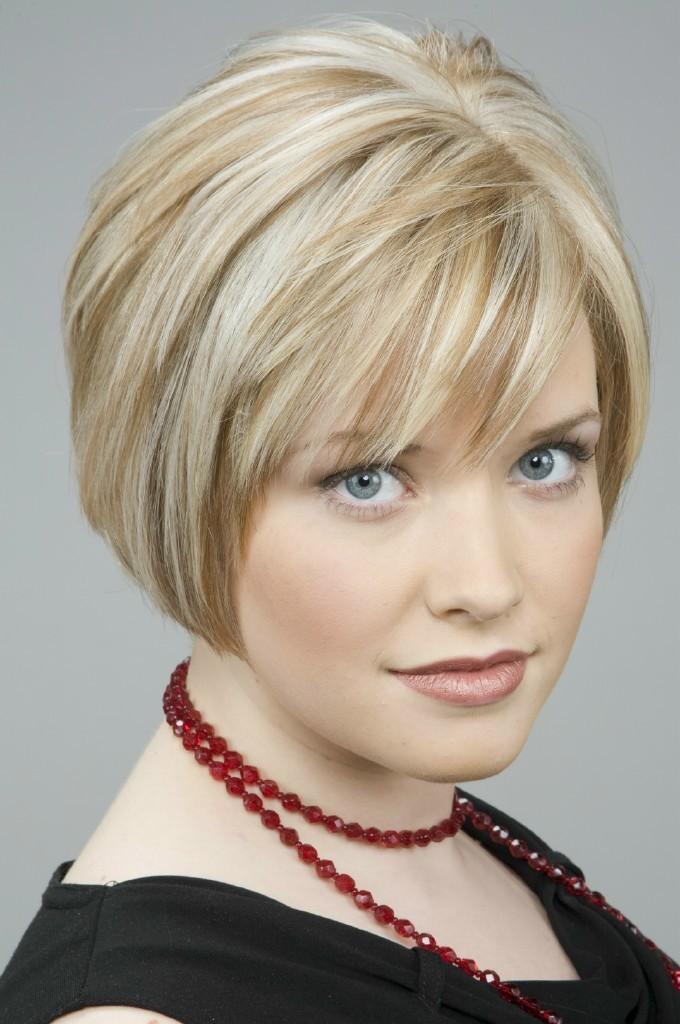How would you summarize this image in a sentence or two? This is the picture of a lady in black top and also we can see a chain around her neck which is in maroon color. 